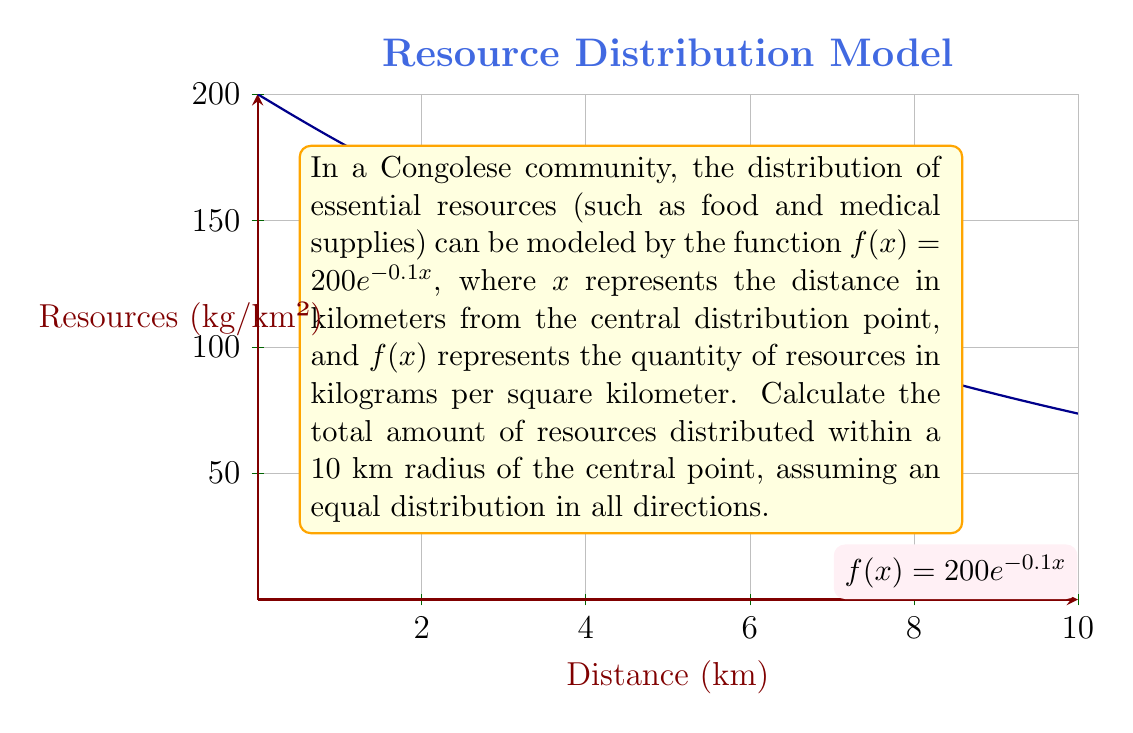Give your solution to this math problem. To solve this problem, we need to calculate the integral of the given function over a circular area with a radius of 10 km. Let's approach this step-by-step:

1) The total amount of resources is the volume under the surface generated by rotating the curve $f(x) = 200e^{-0.1x}$ around the y-axis from 0 to 10 km.

2) This can be calculated using the formula for the volume of a solid of revolution:

   $$V = 2\pi \int_0^{10} xf(x) dx$$

3) Substituting our function:

   $$V = 2\pi \int_0^{10} x(200e^{-0.1x}) dx = 400\pi \int_0^{10} xe^{-0.1x} dx$$

4) To solve this integral, we can use integration by parts. Let $u = x$ and $dv = e^{-0.1x}dx$. Then $du = dx$ and $v = -10e^{-0.1x}$.

5) Applying the integration by parts formula:

   $$V = 400\pi \left[-10xe^{-0.1x}\right]_0^{10} + 400\pi \int_0^{10} 10e^{-0.1x} dx$$

6) Evaluating the first part:

   $$-400\pi \cdot 10 \cdot 10e^{-1} + 0 = -4000\pi e^{-1}$$

7) For the second part:

   $$4000\pi \int_0^{10} e^{-0.1x} dx = 4000\pi \left[-10e^{-0.1x}\right]_0^{10} = 4000\pi \left(-10e^{-1} + 10\right)$$

8) Combining the results:

   $$V = -4000\pi e^{-1} + 4000\pi \left(-10e^{-1} + 10\right) = 4000\pi \left(10 - 11e^{-1}\right)$$

9) This gives us the total volume in cubic kilometers. To convert to kilograms, we multiply by 1000:

   $$\text{Total resources} = 4000000\pi \left(10 - 11e^{-1}\right) \text{ kg}$$
Answer: $4000000\pi \left(10 - 11e^{-1}\right)$ kg 